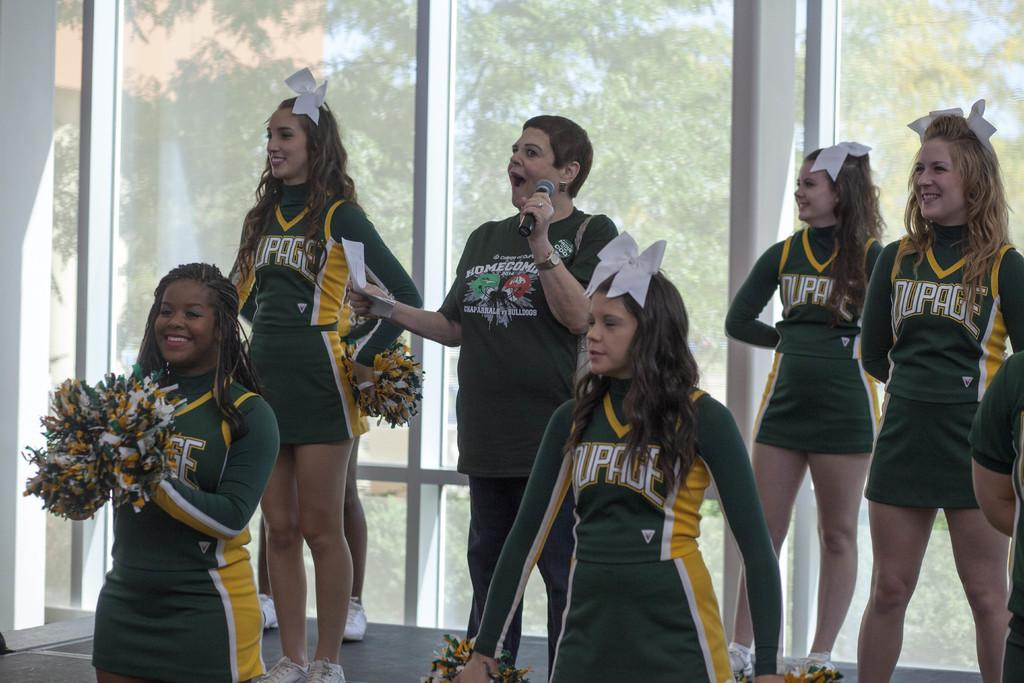<image>
Relay a brief, clear account of the picture shown. Cheerleaders wearing green tops that say "Dupage" on it. 